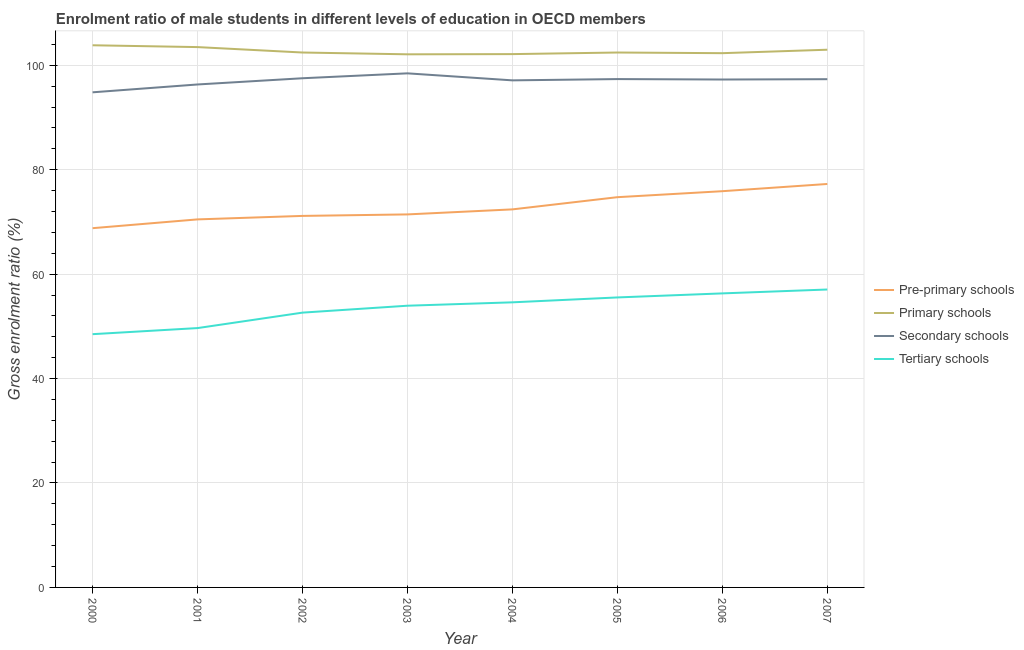Does the line corresponding to gross enrolment ratio(female) in pre-primary schools intersect with the line corresponding to gross enrolment ratio(female) in tertiary schools?
Offer a terse response. No. What is the gross enrolment ratio(female) in pre-primary schools in 2003?
Your answer should be very brief. 71.44. Across all years, what is the maximum gross enrolment ratio(female) in secondary schools?
Offer a very short reply. 98.45. Across all years, what is the minimum gross enrolment ratio(female) in tertiary schools?
Offer a terse response. 48.5. In which year was the gross enrolment ratio(female) in pre-primary schools maximum?
Provide a short and direct response. 2007. What is the total gross enrolment ratio(female) in tertiary schools in the graph?
Provide a short and direct response. 428.23. What is the difference between the gross enrolment ratio(female) in secondary schools in 2005 and that in 2007?
Offer a very short reply. 0.02. What is the difference between the gross enrolment ratio(female) in tertiary schools in 2001 and the gross enrolment ratio(female) in primary schools in 2003?
Offer a very short reply. -52.43. What is the average gross enrolment ratio(female) in secondary schools per year?
Offer a terse response. 97.02. In the year 2007, what is the difference between the gross enrolment ratio(female) in secondary schools and gross enrolment ratio(female) in pre-primary schools?
Give a very brief answer. 20.07. What is the ratio of the gross enrolment ratio(female) in tertiary schools in 2000 to that in 2006?
Offer a terse response. 0.86. Is the gross enrolment ratio(female) in pre-primary schools in 2000 less than that in 2004?
Your answer should be compact. Yes. Is the difference between the gross enrolment ratio(female) in tertiary schools in 2000 and 2007 greater than the difference between the gross enrolment ratio(female) in secondary schools in 2000 and 2007?
Give a very brief answer. No. What is the difference between the highest and the second highest gross enrolment ratio(female) in secondary schools?
Your answer should be very brief. 0.94. What is the difference between the highest and the lowest gross enrolment ratio(female) in tertiary schools?
Keep it short and to the point. 8.55. In how many years, is the gross enrolment ratio(female) in secondary schools greater than the average gross enrolment ratio(female) in secondary schools taken over all years?
Your answer should be very brief. 6. Is it the case that in every year, the sum of the gross enrolment ratio(female) in pre-primary schools and gross enrolment ratio(female) in primary schools is greater than the gross enrolment ratio(female) in secondary schools?
Offer a very short reply. Yes. How many years are there in the graph?
Offer a terse response. 8. Are the values on the major ticks of Y-axis written in scientific E-notation?
Give a very brief answer. No. Does the graph contain grids?
Make the answer very short. Yes. What is the title of the graph?
Offer a terse response. Enrolment ratio of male students in different levels of education in OECD members. What is the Gross enrolment ratio (%) of Pre-primary schools in 2000?
Offer a very short reply. 68.8. What is the Gross enrolment ratio (%) in Primary schools in 2000?
Make the answer very short. 103.83. What is the Gross enrolment ratio (%) of Secondary schools in 2000?
Give a very brief answer. 94.82. What is the Gross enrolment ratio (%) of Tertiary schools in 2000?
Offer a very short reply. 48.5. What is the Gross enrolment ratio (%) of Pre-primary schools in 2001?
Offer a very short reply. 70.48. What is the Gross enrolment ratio (%) in Primary schools in 2001?
Keep it short and to the point. 103.48. What is the Gross enrolment ratio (%) in Secondary schools in 2001?
Your answer should be very brief. 96.32. What is the Gross enrolment ratio (%) of Tertiary schools in 2001?
Make the answer very short. 49.67. What is the Gross enrolment ratio (%) of Pre-primary schools in 2002?
Your response must be concise. 71.15. What is the Gross enrolment ratio (%) of Primary schools in 2002?
Give a very brief answer. 102.44. What is the Gross enrolment ratio (%) of Secondary schools in 2002?
Provide a succinct answer. 97.51. What is the Gross enrolment ratio (%) of Tertiary schools in 2002?
Make the answer very short. 52.63. What is the Gross enrolment ratio (%) of Pre-primary schools in 2003?
Ensure brevity in your answer.  71.44. What is the Gross enrolment ratio (%) in Primary schools in 2003?
Ensure brevity in your answer.  102.09. What is the Gross enrolment ratio (%) in Secondary schools in 2003?
Offer a very short reply. 98.45. What is the Gross enrolment ratio (%) of Tertiary schools in 2003?
Make the answer very short. 53.95. What is the Gross enrolment ratio (%) of Pre-primary schools in 2004?
Ensure brevity in your answer.  72.4. What is the Gross enrolment ratio (%) in Primary schools in 2004?
Your answer should be very brief. 102.13. What is the Gross enrolment ratio (%) of Secondary schools in 2004?
Your answer should be very brief. 97.11. What is the Gross enrolment ratio (%) in Tertiary schools in 2004?
Keep it short and to the point. 54.6. What is the Gross enrolment ratio (%) of Pre-primary schools in 2005?
Provide a succinct answer. 74.73. What is the Gross enrolment ratio (%) of Primary schools in 2005?
Your response must be concise. 102.44. What is the Gross enrolment ratio (%) in Secondary schools in 2005?
Offer a very short reply. 97.35. What is the Gross enrolment ratio (%) in Tertiary schools in 2005?
Give a very brief answer. 55.53. What is the Gross enrolment ratio (%) of Pre-primary schools in 2006?
Your answer should be very brief. 75.88. What is the Gross enrolment ratio (%) of Primary schools in 2006?
Provide a short and direct response. 102.31. What is the Gross enrolment ratio (%) in Secondary schools in 2006?
Keep it short and to the point. 97.27. What is the Gross enrolment ratio (%) in Tertiary schools in 2006?
Ensure brevity in your answer.  56.31. What is the Gross enrolment ratio (%) in Pre-primary schools in 2007?
Ensure brevity in your answer.  77.26. What is the Gross enrolment ratio (%) of Primary schools in 2007?
Offer a very short reply. 102.97. What is the Gross enrolment ratio (%) of Secondary schools in 2007?
Provide a short and direct response. 97.33. What is the Gross enrolment ratio (%) of Tertiary schools in 2007?
Your answer should be very brief. 57.05. Across all years, what is the maximum Gross enrolment ratio (%) in Pre-primary schools?
Your response must be concise. 77.26. Across all years, what is the maximum Gross enrolment ratio (%) of Primary schools?
Offer a very short reply. 103.83. Across all years, what is the maximum Gross enrolment ratio (%) of Secondary schools?
Your response must be concise. 98.45. Across all years, what is the maximum Gross enrolment ratio (%) of Tertiary schools?
Provide a short and direct response. 57.05. Across all years, what is the minimum Gross enrolment ratio (%) in Pre-primary schools?
Provide a short and direct response. 68.8. Across all years, what is the minimum Gross enrolment ratio (%) of Primary schools?
Offer a very short reply. 102.09. Across all years, what is the minimum Gross enrolment ratio (%) of Secondary schools?
Your answer should be compact. 94.82. Across all years, what is the minimum Gross enrolment ratio (%) of Tertiary schools?
Give a very brief answer. 48.5. What is the total Gross enrolment ratio (%) in Pre-primary schools in the graph?
Offer a very short reply. 582.13. What is the total Gross enrolment ratio (%) in Primary schools in the graph?
Your answer should be very brief. 821.69. What is the total Gross enrolment ratio (%) of Secondary schools in the graph?
Make the answer very short. 776.14. What is the total Gross enrolment ratio (%) in Tertiary schools in the graph?
Offer a very short reply. 428.23. What is the difference between the Gross enrolment ratio (%) of Pre-primary schools in 2000 and that in 2001?
Provide a succinct answer. -1.68. What is the difference between the Gross enrolment ratio (%) of Primary schools in 2000 and that in 2001?
Your answer should be very brief. 0.35. What is the difference between the Gross enrolment ratio (%) of Secondary schools in 2000 and that in 2001?
Keep it short and to the point. -1.5. What is the difference between the Gross enrolment ratio (%) of Tertiary schools in 2000 and that in 2001?
Your answer should be very brief. -1.17. What is the difference between the Gross enrolment ratio (%) of Pre-primary schools in 2000 and that in 2002?
Offer a terse response. -2.35. What is the difference between the Gross enrolment ratio (%) of Primary schools in 2000 and that in 2002?
Make the answer very short. 1.39. What is the difference between the Gross enrolment ratio (%) in Secondary schools in 2000 and that in 2002?
Your response must be concise. -2.69. What is the difference between the Gross enrolment ratio (%) in Tertiary schools in 2000 and that in 2002?
Provide a short and direct response. -4.13. What is the difference between the Gross enrolment ratio (%) in Pre-primary schools in 2000 and that in 2003?
Your answer should be compact. -2.64. What is the difference between the Gross enrolment ratio (%) in Primary schools in 2000 and that in 2003?
Your answer should be very brief. 1.73. What is the difference between the Gross enrolment ratio (%) of Secondary schools in 2000 and that in 2003?
Make the answer very short. -3.63. What is the difference between the Gross enrolment ratio (%) of Tertiary schools in 2000 and that in 2003?
Offer a terse response. -5.45. What is the difference between the Gross enrolment ratio (%) of Pre-primary schools in 2000 and that in 2004?
Your answer should be very brief. -3.6. What is the difference between the Gross enrolment ratio (%) in Primary schools in 2000 and that in 2004?
Keep it short and to the point. 1.69. What is the difference between the Gross enrolment ratio (%) of Secondary schools in 2000 and that in 2004?
Your answer should be compact. -2.29. What is the difference between the Gross enrolment ratio (%) in Tertiary schools in 2000 and that in 2004?
Offer a very short reply. -6.1. What is the difference between the Gross enrolment ratio (%) in Pre-primary schools in 2000 and that in 2005?
Give a very brief answer. -5.94. What is the difference between the Gross enrolment ratio (%) in Primary schools in 2000 and that in 2005?
Offer a very short reply. 1.39. What is the difference between the Gross enrolment ratio (%) of Secondary schools in 2000 and that in 2005?
Your answer should be compact. -2.54. What is the difference between the Gross enrolment ratio (%) of Tertiary schools in 2000 and that in 2005?
Offer a terse response. -7.03. What is the difference between the Gross enrolment ratio (%) in Pre-primary schools in 2000 and that in 2006?
Your answer should be compact. -7.08. What is the difference between the Gross enrolment ratio (%) of Primary schools in 2000 and that in 2006?
Your answer should be very brief. 1.51. What is the difference between the Gross enrolment ratio (%) in Secondary schools in 2000 and that in 2006?
Offer a very short reply. -2.45. What is the difference between the Gross enrolment ratio (%) in Tertiary schools in 2000 and that in 2006?
Ensure brevity in your answer.  -7.81. What is the difference between the Gross enrolment ratio (%) in Pre-primary schools in 2000 and that in 2007?
Keep it short and to the point. -8.47. What is the difference between the Gross enrolment ratio (%) in Primary schools in 2000 and that in 2007?
Ensure brevity in your answer.  0.85. What is the difference between the Gross enrolment ratio (%) in Secondary schools in 2000 and that in 2007?
Your answer should be compact. -2.51. What is the difference between the Gross enrolment ratio (%) in Tertiary schools in 2000 and that in 2007?
Give a very brief answer. -8.55. What is the difference between the Gross enrolment ratio (%) in Pre-primary schools in 2001 and that in 2002?
Your answer should be very brief. -0.67. What is the difference between the Gross enrolment ratio (%) of Primary schools in 2001 and that in 2002?
Your answer should be compact. 1.04. What is the difference between the Gross enrolment ratio (%) in Secondary schools in 2001 and that in 2002?
Your response must be concise. -1.19. What is the difference between the Gross enrolment ratio (%) of Tertiary schools in 2001 and that in 2002?
Offer a terse response. -2.96. What is the difference between the Gross enrolment ratio (%) of Pre-primary schools in 2001 and that in 2003?
Provide a short and direct response. -0.96. What is the difference between the Gross enrolment ratio (%) in Primary schools in 2001 and that in 2003?
Your response must be concise. 1.38. What is the difference between the Gross enrolment ratio (%) in Secondary schools in 2001 and that in 2003?
Your response must be concise. -2.13. What is the difference between the Gross enrolment ratio (%) of Tertiary schools in 2001 and that in 2003?
Your response must be concise. -4.28. What is the difference between the Gross enrolment ratio (%) of Pre-primary schools in 2001 and that in 2004?
Your answer should be compact. -1.92. What is the difference between the Gross enrolment ratio (%) of Primary schools in 2001 and that in 2004?
Make the answer very short. 1.34. What is the difference between the Gross enrolment ratio (%) of Secondary schools in 2001 and that in 2004?
Your response must be concise. -0.79. What is the difference between the Gross enrolment ratio (%) in Tertiary schools in 2001 and that in 2004?
Offer a terse response. -4.93. What is the difference between the Gross enrolment ratio (%) in Pre-primary schools in 2001 and that in 2005?
Your answer should be very brief. -4.25. What is the difference between the Gross enrolment ratio (%) in Primary schools in 2001 and that in 2005?
Offer a very short reply. 1.04. What is the difference between the Gross enrolment ratio (%) of Secondary schools in 2001 and that in 2005?
Offer a very short reply. -1.03. What is the difference between the Gross enrolment ratio (%) of Tertiary schools in 2001 and that in 2005?
Your response must be concise. -5.87. What is the difference between the Gross enrolment ratio (%) of Pre-primary schools in 2001 and that in 2006?
Provide a short and direct response. -5.4. What is the difference between the Gross enrolment ratio (%) in Primary schools in 2001 and that in 2006?
Provide a short and direct response. 1.16. What is the difference between the Gross enrolment ratio (%) of Secondary schools in 2001 and that in 2006?
Provide a succinct answer. -0.95. What is the difference between the Gross enrolment ratio (%) in Tertiary schools in 2001 and that in 2006?
Provide a short and direct response. -6.64. What is the difference between the Gross enrolment ratio (%) in Pre-primary schools in 2001 and that in 2007?
Offer a terse response. -6.78. What is the difference between the Gross enrolment ratio (%) of Primary schools in 2001 and that in 2007?
Provide a succinct answer. 0.5. What is the difference between the Gross enrolment ratio (%) of Secondary schools in 2001 and that in 2007?
Give a very brief answer. -1.01. What is the difference between the Gross enrolment ratio (%) in Tertiary schools in 2001 and that in 2007?
Give a very brief answer. -7.39. What is the difference between the Gross enrolment ratio (%) of Pre-primary schools in 2002 and that in 2003?
Keep it short and to the point. -0.29. What is the difference between the Gross enrolment ratio (%) in Primary schools in 2002 and that in 2003?
Make the answer very short. 0.34. What is the difference between the Gross enrolment ratio (%) of Secondary schools in 2002 and that in 2003?
Ensure brevity in your answer.  -0.94. What is the difference between the Gross enrolment ratio (%) in Tertiary schools in 2002 and that in 2003?
Make the answer very short. -1.32. What is the difference between the Gross enrolment ratio (%) in Pre-primary schools in 2002 and that in 2004?
Offer a very short reply. -1.25. What is the difference between the Gross enrolment ratio (%) in Primary schools in 2002 and that in 2004?
Provide a short and direct response. 0.3. What is the difference between the Gross enrolment ratio (%) in Secondary schools in 2002 and that in 2004?
Offer a terse response. 0.4. What is the difference between the Gross enrolment ratio (%) in Tertiary schools in 2002 and that in 2004?
Ensure brevity in your answer.  -1.97. What is the difference between the Gross enrolment ratio (%) in Pre-primary schools in 2002 and that in 2005?
Offer a very short reply. -3.59. What is the difference between the Gross enrolment ratio (%) of Primary schools in 2002 and that in 2005?
Give a very brief answer. -0. What is the difference between the Gross enrolment ratio (%) of Secondary schools in 2002 and that in 2005?
Provide a short and direct response. 0.16. What is the difference between the Gross enrolment ratio (%) in Tertiary schools in 2002 and that in 2005?
Offer a terse response. -2.91. What is the difference between the Gross enrolment ratio (%) of Pre-primary schools in 2002 and that in 2006?
Provide a succinct answer. -4.73. What is the difference between the Gross enrolment ratio (%) in Primary schools in 2002 and that in 2006?
Your response must be concise. 0.12. What is the difference between the Gross enrolment ratio (%) in Secondary schools in 2002 and that in 2006?
Give a very brief answer. 0.24. What is the difference between the Gross enrolment ratio (%) in Tertiary schools in 2002 and that in 2006?
Offer a very short reply. -3.68. What is the difference between the Gross enrolment ratio (%) of Pre-primary schools in 2002 and that in 2007?
Provide a succinct answer. -6.12. What is the difference between the Gross enrolment ratio (%) in Primary schools in 2002 and that in 2007?
Your response must be concise. -0.54. What is the difference between the Gross enrolment ratio (%) of Secondary schools in 2002 and that in 2007?
Offer a very short reply. 0.18. What is the difference between the Gross enrolment ratio (%) in Tertiary schools in 2002 and that in 2007?
Your answer should be very brief. -4.43. What is the difference between the Gross enrolment ratio (%) of Pre-primary schools in 2003 and that in 2004?
Provide a short and direct response. -0.96. What is the difference between the Gross enrolment ratio (%) of Primary schools in 2003 and that in 2004?
Make the answer very short. -0.04. What is the difference between the Gross enrolment ratio (%) of Secondary schools in 2003 and that in 2004?
Give a very brief answer. 1.34. What is the difference between the Gross enrolment ratio (%) of Tertiary schools in 2003 and that in 2004?
Keep it short and to the point. -0.65. What is the difference between the Gross enrolment ratio (%) of Pre-primary schools in 2003 and that in 2005?
Your answer should be very brief. -3.3. What is the difference between the Gross enrolment ratio (%) of Primary schools in 2003 and that in 2005?
Your answer should be compact. -0.34. What is the difference between the Gross enrolment ratio (%) in Secondary schools in 2003 and that in 2005?
Ensure brevity in your answer.  1.1. What is the difference between the Gross enrolment ratio (%) of Tertiary schools in 2003 and that in 2005?
Provide a short and direct response. -1.59. What is the difference between the Gross enrolment ratio (%) in Pre-primary schools in 2003 and that in 2006?
Your answer should be compact. -4.44. What is the difference between the Gross enrolment ratio (%) of Primary schools in 2003 and that in 2006?
Provide a succinct answer. -0.22. What is the difference between the Gross enrolment ratio (%) of Secondary schools in 2003 and that in 2006?
Keep it short and to the point. 1.18. What is the difference between the Gross enrolment ratio (%) in Tertiary schools in 2003 and that in 2006?
Ensure brevity in your answer.  -2.36. What is the difference between the Gross enrolment ratio (%) of Pre-primary schools in 2003 and that in 2007?
Offer a very short reply. -5.83. What is the difference between the Gross enrolment ratio (%) of Primary schools in 2003 and that in 2007?
Keep it short and to the point. -0.88. What is the difference between the Gross enrolment ratio (%) in Secondary schools in 2003 and that in 2007?
Keep it short and to the point. 1.12. What is the difference between the Gross enrolment ratio (%) in Tertiary schools in 2003 and that in 2007?
Give a very brief answer. -3.1. What is the difference between the Gross enrolment ratio (%) in Pre-primary schools in 2004 and that in 2005?
Give a very brief answer. -2.34. What is the difference between the Gross enrolment ratio (%) of Primary schools in 2004 and that in 2005?
Your answer should be compact. -0.3. What is the difference between the Gross enrolment ratio (%) of Secondary schools in 2004 and that in 2005?
Give a very brief answer. -0.24. What is the difference between the Gross enrolment ratio (%) of Tertiary schools in 2004 and that in 2005?
Give a very brief answer. -0.94. What is the difference between the Gross enrolment ratio (%) in Pre-primary schools in 2004 and that in 2006?
Ensure brevity in your answer.  -3.48. What is the difference between the Gross enrolment ratio (%) in Primary schools in 2004 and that in 2006?
Give a very brief answer. -0.18. What is the difference between the Gross enrolment ratio (%) of Secondary schools in 2004 and that in 2006?
Your answer should be compact. -0.16. What is the difference between the Gross enrolment ratio (%) of Tertiary schools in 2004 and that in 2006?
Ensure brevity in your answer.  -1.71. What is the difference between the Gross enrolment ratio (%) of Pre-primary schools in 2004 and that in 2007?
Your answer should be very brief. -4.86. What is the difference between the Gross enrolment ratio (%) in Primary schools in 2004 and that in 2007?
Provide a succinct answer. -0.84. What is the difference between the Gross enrolment ratio (%) in Secondary schools in 2004 and that in 2007?
Your response must be concise. -0.22. What is the difference between the Gross enrolment ratio (%) of Tertiary schools in 2004 and that in 2007?
Your answer should be compact. -2.46. What is the difference between the Gross enrolment ratio (%) of Pre-primary schools in 2005 and that in 2006?
Keep it short and to the point. -1.15. What is the difference between the Gross enrolment ratio (%) of Primary schools in 2005 and that in 2006?
Make the answer very short. 0.12. What is the difference between the Gross enrolment ratio (%) of Secondary schools in 2005 and that in 2006?
Keep it short and to the point. 0.09. What is the difference between the Gross enrolment ratio (%) of Tertiary schools in 2005 and that in 2006?
Your response must be concise. -0.77. What is the difference between the Gross enrolment ratio (%) of Pre-primary schools in 2005 and that in 2007?
Make the answer very short. -2.53. What is the difference between the Gross enrolment ratio (%) of Primary schools in 2005 and that in 2007?
Offer a terse response. -0.54. What is the difference between the Gross enrolment ratio (%) of Secondary schools in 2005 and that in 2007?
Provide a short and direct response. 0.02. What is the difference between the Gross enrolment ratio (%) in Tertiary schools in 2005 and that in 2007?
Make the answer very short. -1.52. What is the difference between the Gross enrolment ratio (%) of Pre-primary schools in 2006 and that in 2007?
Your answer should be very brief. -1.38. What is the difference between the Gross enrolment ratio (%) of Primary schools in 2006 and that in 2007?
Your answer should be compact. -0.66. What is the difference between the Gross enrolment ratio (%) in Secondary schools in 2006 and that in 2007?
Your response must be concise. -0.06. What is the difference between the Gross enrolment ratio (%) of Tertiary schools in 2006 and that in 2007?
Offer a very short reply. -0.74. What is the difference between the Gross enrolment ratio (%) in Pre-primary schools in 2000 and the Gross enrolment ratio (%) in Primary schools in 2001?
Your response must be concise. -34.68. What is the difference between the Gross enrolment ratio (%) in Pre-primary schools in 2000 and the Gross enrolment ratio (%) in Secondary schools in 2001?
Offer a very short reply. -27.52. What is the difference between the Gross enrolment ratio (%) of Pre-primary schools in 2000 and the Gross enrolment ratio (%) of Tertiary schools in 2001?
Your answer should be very brief. 19.13. What is the difference between the Gross enrolment ratio (%) in Primary schools in 2000 and the Gross enrolment ratio (%) in Secondary schools in 2001?
Provide a succinct answer. 7.51. What is the difference between the Gross enrolment ratio (%) in Primary schools in 2000 and the Gross enrolment ratio (%) in Tertiary schools in 2001?
Provide a short and direct response. 54.16. What is the difference between the Gross enrolment ratio (%) of Secondary schools in 2000 and the Gross enrolment ratio (%) of Tertiary schools in 2001?
Your answer should be compact. 45.15. What is the difference between the Gross enrolment ratio (%) in Pre-primary schools in 2000 and the Gross enrolment ratio (%) in Primary schools in 2002?
Ensure brevity in your answer.  -33.64. What is the difference between the Gross enrolment ratio (%) of Pre-primary schools in 2000 and the Gross enrolment ratio (%) of Secondary schools in 2002?
Give a very brief answer. -28.71. What is the difference between the Gross enrolment ratio (%) of Pre-primary schools in 2000 and the Gross enrolment ratio (%) of Tertiary schools in 2002?
Provide a short and direct response. 16.17. What is the difference between the Gross enrolment ratio (%) of Primary schools in 2000 and the Gross enrolment ratio (%) of Secondary schools in 2002?
Make the answer very short. 6.32. What is the difference between the Gross enrolment ratio (%) in Primary schools in 2000 and the Gross enrolment ratio (%) in Tertiary schools in 2002?
Provide a short and direct response. 51.2. What is the difference between the Gross enrolment ratio (%) in Secondary schools in 2000 and the Gross enrolment ratio (%) in Tertiary schools in 2002?
Give a very brief answer. 42.19. What is the difference between the Gross enrolment ratio (%) of Pre-primary schools in 2000 and the Gross enrolment ratio (%) of Primary schools in 2003?
Offer a terse response. -33.3. What is the difference between the Gross enrolment ratio (%) in Pre-primary schools in 2000 and the Gross enrolment ratio (%) in Secondary schools in 2003?
Give a very brief answer. -29.65. What is the difference between the Gross enrolment ratio (%) in Pre-primary schools in 2000 and the Gross enrolment ratio (%) in Tertiary schools in 2003?
Offer a terse response. 14.85. What is the difference between the Gross enrolment ratio (%) in Primary schools in 2000 and the Gross enrolment ratio (%) in Secondary schools in 2003?
Your answer should be very brief. 5.38. What is the difference between the Gross enrolment ratio (%) of Primary schools in 2000 and the Gross enrolment ratio (%) of Tertiary schools in 2003?
Your answer should be compact. 49.88. What is the difference between the Gross enrolment ratio (%) in Secondary schools in 2000 and the Gross enrolment ratio (%) in Tertiary schools in 2003?
Offer a very short reply. 40.87. What is the difference between the Gross enrolment ratio (%) in Pre-primary schools in 2000 and the Gross enrolment ratio (%) in Primary schools in 2004?
Your response must be concise. -33.34. What is the difference between the Gross enrolment ratio (%) in Pre-primary schools in 2000 and the Gross enrolment ratio (%) in Secondary schools in 2004?
Provide a short and direct response. -28.31. What is the difference between the Gross enrolment ratio (%) in Pre-primary schools in 2000 and the Gross enrolment ratio (%) in Tertiary schools in 2004?
Give a very brief answer. 14.2. What is the difference between the Gross enrolment ratio (%) in Primary schools in 2000 and the Gross enrolment ratio (%) in Secondary schools in 2004?
Ensure brevity in your answer.  6.72. What is the difference between the Gross enrolment ratio (%) of Primary schools in 2000 and the Gross enrolment ratio (%) of Tertiary schools in 2004?
Offer a very short reply. 49.23. What is the difference between the Gross enrolment ratio (%) of Secondary schools in 2000 and the Gross enrolment ratio (%) of Tertiary schools in 2004?
Your answer should be very brief. 40.22. What is the difference between the Gross enrolment ratio (%) in Pre-primary schools in 2000 and the Gross enrolment ratio (%) in Primary schools in 2005?
Provide a succinct answer. -33.64. What is the difference between the Gross enrolment ratio (%) in Pre-primary schools in 2000 and the Gross enrolment ratio (%) in Secondary schools in 2005?
Ensure brevity in your answer.  -28.55. What is the difference between the Gross enrolment ratio (%) in Pre-primary schools in 2000 and the Gross enrolment ratio (%) in Tertiary schools in 2005?
Make the answer very short. 13.26. What is the difference between the Gross enrolment ratio (%) of Primary schools in 2000 and the Gross enrolment ratio (%) of Secondary schools in 2005?
Provide a short and direct response. 6.47. What is the difference between the Gross enrolment ratio (%) of Primary schools in 2000 and the Gross enrolment ratio (%) of Tertiary schools in 2005?
Provide a succinct answer. 48.29. What is the difference between the Gross enrolment ratio (%) in Secondary schools in 2000 and the Gross enrolment ratio (%) in Tertiary schools in 2005?
Provide a short and direct response. 39.28. What is the difference between the Gross enrolment ratio (%) of Pre-primary schools in 2000 and the Gross enrolment ratio (%) of Primary schools in 2006?
Your answer should be very brief. -33.52. What is the difference between the Gross enrolment ratio (%) of Pre-primary schools in 2000 and the Gross enrolment ratio (%) of Secondary schools in 2006?
Make the answer very short. -28.47. What is the difference between the Gross enrolment ratio (%) in Pre-primary schools in 2000 and the Gross enrolment ratio (%) in Tertiary schools in 2006?
Offer a very short reply. 12.49. What is the difference between the Gross enrolment ratio (%) in Primary schools in 2000 and the Gross enrolment ratio (%) in Secondary schools in 2006?
Your response must be concise. 6.56. What is the difference between the Gross enrolment ratio (%) of Primary schools in 2000 and the Gross enrolment ratio (%) of Tertiary schools in 2006?
Give a very brief answer. 47.52. What is the difference between the Gross enrolment ratio (%) of Secondary schools in 2000 and the Gross enrolment ratio (%) of Tertiary schools in 2006?
Your response must be concise. 38.51. What is the difference between the Gross enrolment ratio (%) in Pre-primary schools in 2000 and the Gross enrolment ratio (%) in Primary schools in 2007?
Keep it short and to the point. -34.18. What is the difference between the Gross enrolment ratio (%) in Pre-primary schools in 2000 and the Gross enrolment ratio (%) in Secondary schools in 2007?
Provide a succinct answer. -28.53. What is the difference between the Gross enrolment ratio (%) in Pre-primary schools in 2000 and the Gross enrolment ratio (%) in Tertiary schools in 2007?
Provide a succinct answer. 11.74. What is the difference between the Gross enrolment ratio (%) in Primary schools in 2000 and the Gross enrolment ratio (%) in Secondary schools in 2007?
Provide a succinct answer. 6.5. What is the difference between the Gross enrolment ratio (%) of Primary schools in 2000 and the Gross enrolment ratio (%) of Tertiary schools in 2007?
Provide a succinct answer. 46.77. What is the difference between the Gross enrolment ratio (%) in Secondary schools in 2000 and the Gross enrolment ratio (%) in Tertiary schools in 2007?
Keep it short and to the point. 37.76. What is the difference between the Gross enrolment ratio (%) in Pre-primary schools in 2001 and the Gross enrolment ratio (%) in Primary schools in 2002?
Your response must be concise. -31.96. What is the difference between the Gross enrolment ratio (%) of Pre-primary schools in 2001 and the Gross enrolment ratio (%) of Secondary schools in 2002?
Give a very brief answer. -27.03. What is the difference between the Gross enrolment ratio (%) in Pre-primary schools in 2001 and the Gross enrolment ratio (%) in Tertiary schools in 2002?
Your response must be concise. 17.85. What is the difference between the Gross enrolment ratio (%) of Primary schools in 2001 and the Gross enrolment ratio (%) of Secondary schools in 2002?
Provide a short and direct response. 5.97. What is the difference between the Gross enrolment ratio (%) in Primary schools in 2001 and the Gross enrolment ratio (%) in Tertiary schools in 2002?
Your answer should be compact. 50.85. What is the difference between the Gross enrolment ratio (%) of Secondary schools in 2001 and the Gross enrolment ratio (%) of Tertiary schools in 2002?
Give a very brief answer. 43.69. What is the difference between the Gross enrolment ratio (%) in Pre-primary schools in 2001 and the Gross enrolment ratio (%) in Primary schools in 2003?
Your answer should be compact. -31.61. What is the difference between the Gross enrolment ratio (%) in Pre-primary schools in 2001 and the Gross enrolment ratio (%) in Secondary schools in 2003?
Provide a succinct answer. -27.97. What is the difference between the Gross enrolment ratio (%) of Pre-primary schools in 2001 and the Gross enrolment ratio (%) of Tertiary schools in 2003?
Make the answer very short. 16.53. What is the difference between the Gross enrolment ratio (%) of Primary schools in 2001 and the Gross enrolment ratio (%) of Secondary schools in 2003?
Offer a terse response. 5.03. What is the difference between the Gross enrolment ratio (%) in Primary schools in 2001 and the Gross enrolment ratio (%) in Tertiary schools in 2003?
Offer a very short reply. 49.53. What is the difference between the Gross enrolment ratio (%) in Secondary schools in 2001 and the Gross enrolment ratio (%) in Tertiary schools in 2003?
Offer a very short reply. 42.37. What is the difference between the Gross enrolment ratio (%) of Pre-primary schools in 2001 and the Gross enrolment ratio (%) of Primary schools in 2004?
Your answer should be very brief. -31.65. What is the difference between the Gross enrolment ratio (%) of Pre-primary schools in 2001 and the Gross enrolment ratio (%) of Secondary schools in 2004?
Your answer should be very brief. -26.63. What is the difference between the Gross enrolment ratio (%) in Pre-primary schools in 2001 and the Gross enrolment ratio (%) in Tertiary schools in 2004?
Ensure brevity in your answer.  15.88. What is the difference between the Gross enrolment ratio (%) in Primary schools in 2001 and the Gross enrolment ratio (%) in Secondary schools in 2004?
Keep it short and to the point. 6.37. What is the difference between the Gross enrolment ratio (%) of Primary schools in 2001 and the Gross enrolment ratio (%) of Tertiary schools in 2004?
Your answer should be very brief. 48.88. What is the difference between the Gross enrolment ratio (%) of Secondary schools in 2001 and the Gross enrolment ratio (%) of Tertiary schools in 2004?
Offer a terse response. 41.72. What is the difference between the Gross enrolment ratio (%) in Pre-primary schools in 2001 and the Gross enrolment ratio (%) in Primary schools in 2005?
Provide a short and direct response. -31.96. What is the difference between the Gross enrolment ratio (%) of Pre-primary schools in 2001 and the Gross enrolment ratio (%) of Secondary schools in 2005?
Your answer should be very brief. -26.87. What is the difference between the Gross enrolment ratio (%) of Pre-primary schools in 2001 and the Gross enrolment ratio (%) of Tertiary schools in 2005?
Your answer should be compact. 14.95. What is the difference between the Gross enrolment ratio (%) of Primary schools in 2001 and the Gross enrolment ratio (%) of Secondary schools in 2005?
Provide a succinct answer. 6.12. What is the difference between the Gross enrolment ratio (%) in Primary schools in 2001 and the Gross enrolment ratio (%) in Tertiary schools in 2005?
Your response must be concise. 47.94. What is the difference between the Gross enrolment ratio (%) in Secondary schools in 2001 and the Gross enrolment ratio (%) in Tertiary schools in 2005?
Give a very brief answer. 40.78. What is the difference between the Gross enrolment ratio (%) in Pre-primary schools in 2001 and the Gross enrolment ratio (%) in Primary schools in 2006?
Give a very brief answer. -31.83. What is the difference between the Gross enrolment ratio (%) in Pre-primary schools in 2001 and the Gross enrolment ratio (%) in Secondary schools in 2006?
Give a very brief answer. -26.79. What is the difference between the Gross enrolment ratio (%) in Pre-primary schools in 2001 and the Gross enrolment ratio (%) in Tertiary schools in 2006?
Provide a succinct answer. 14.17. What is the difference between the Gross enrolment ratio (%) in Primary schools in 2001 and the Gross enrolment ratio (%) in Secondary schools in 2006?
Offer a very short reply. 6.21. What is the difference between the Gross enrolment ratio (%) of Primary schools in 2001 and the Gross enrolment ratio (%) of Tertiary schools in 2006?
Make the answer very short. 47.17. What is the difference between the Gross enrolment ratio (%) of Secondary schools in 2001 and the Gross enrolment ratio (%) of Tertiary schools in 2006?
Ensure brevity in your answer.  40.01. What is the difference between the Gross enrolment ratio (%) in Pre-primary schools in 2001 and the Gross enrolment ratio (%) in Primary schools in 2007?
Offer a very short reply. -32.49. What is the difference between the Gross enrolment ratio (%) of Pre-primary schools in 2001 and the Gross enrolment ratio (%) of Secondary schools in 2007?
Provide a succinct answer. -26.85. What is the difference between the Gross enrolment ratio (%) of Pre-primary schools in 2001 and the Gross enrolment ratio (%) of Tertiary schools in 2007?
Ensure brevity in your answer.  13.43. What is the difference between the Gross enrolment ratio (%) in Primary schools in 2001 and the Gross enrolment ratio (%) in Secondary schools in 2007?
Your response must be concise. 6.15. What is the difference between the Gross enrolment ratio (%) of Primary schools in 2001 and the Gross enrolment ratio (%) of Tertiary schools in 2007?
Your answer should be very brief. 46.42. What is the difference between the Gross enrolment ratio (%) of Secondary schools in 2001 and the Gross enrolment ratio (%) of Tertiary schools in 2007?
Give a very brief answer. 39.27. What is the difference between the Gross enrolment ratio (%) of Pre-primary schools in 2002 and the Gross enrolment ratio (%) of Primary schools in 2003?
Provide a short and direct response. -30.95. What is the difference between the Gross enrolment ratio (%) in Pre-primary schools in 2002 and the Gross enrolment ratio (%) in Secondary schools in 2003?
Make the answer very short. -27.3. What is the difference between the Gross enrolment ratio (%) of Pre-primary schools in 2002 and the Gross enrolment ratio (%) of Tertiary schools in 2003?
Provide a succinct answer. 17.2. What is the difference between the Gross enrolment ratio (%) in Primary schools in 2002 and the Gross enrolment ratio (%) in Secondary schools in 2003?
Provide a short and direct response. 3.99. What is the difference between the Gross enrolment ratio (%) of Primary schools in 2002 and the Gross enrolment ratio (%) of Tertiary schools in 2003?
Make the answer very short. 48.49. What is the difference between the Gross enrolment ratio (%) of Secondary schools in 2002 and the Gross enrolment ratio (%) of Tertiary schools in 2003?
Give a very brief answer. 43.56. What is the difference between the Gross enrolment ratio (%) of Pre-primary schools in 2002 and the Gross enrolment ratio (%) of Primary schools in 2004?
Provide a succinct answer. -30.99. What is the difference between the Gross enrolment ratio (%) of Pre-primary schools in 2002 and the Gross enrolment ratio (%) of Secondary schools in 2004?
Your answer should be very brief. -25.96. What is the difference between the Gross enrolment ratio (%) in Pre-primary schools in 2002 and the Gross enrolment ratio (%) in Tertiary schools in 2004?
Your answer should be very brief. 16.55. What is the difference between the Gross enrolment ratio (%) of Primary schools in 2002 and the Gross enrolment ratio (%) of Secondary schools in 2004?
Keep it short and to the point. 5.33. What is the difference between the Gross enrolment ratio (%) of Primary schools in 2002 and the Gross enrolment ratio (%) of Tertiary schools in 2004?
Provide a short and direct response. 47.84. What is the difference between the Gross enrolment ratio (%) of Secondary schools in 2002 and the Gross enrolment ratio (%) of Tertiary schools in 2004?
Give a very brief answer. 42.91. What is the difference between the Gross enrolment ratio (%) of Pre-primary schools in 2002 and the Gross enrolment ratio (%) of Primary schools in 2005?
Make the answer very short. -31.29. What is the difference between the Gross enrolment ratio (%) in Pre-primary schools in 2002 and the Gross enrolment ratio (%) in Secondary schools in 2005?
Your answer should be compact. -26.2. What is the difference between the Gross enrolment ratio (%) in Pre-primary schools in 2002 and the Gross enrolment ratio (%) in Tertiary schools in 2005?
Offer a very short reply. 15.61. What is the difference between the Gross enrolment ratio (%) of Primary schools in 2002 and the Gross enrolment ratio (%) of Secondary schools in 2005?
Provide a short and direct response. 5.09. What is the difference between the Gross enrolment ratio (%) in Primary schools in 2002 and the Gross enrolment ratio (%) in Tertiary schools in 2005?
Offer a terse response. 46.9. What is the difference between the Gross enrolment ratio (%) in Secondary schools in 2002 and the Gross enrolment ratio (%) in Tertiary schools in 2005?
Ensure brevity in your answer.  41.97. What is the difference between the Gross enrolment ratio (%) of Pre-primary schools in 2002 and the Gross enrolment ratio (%) of Primary schools in 2006?
Give a very brief answer. -31.17. What is the difference between the Gross enrolment ratio (%) of Pre-primary schools in 2002 and the Gross enrolment ratio (%) of Secondary schools in 2006?
Your answer should be compact. -26.12. What is the difference between the Gross enrolment ratio (%) in Pre-primary schools in 2002 and the Gross enrolment ratio (%) in Tertiary schools in 2006?
Provide a short and direct response. 14.84. What is the difference between the Gross enrolment ratio (%) of Primary schools in 2002 and the Gross enrolment ratio (%) of Secondary schools in 2006?
Make the answer very short. 5.17. What is the difference between the Gross enrolment ratio (%) of Primary schools in 2002 and the Gross enrolment ratio (%) of Tertiary schools in 2006?
Your answer should be very brief. 46.13. What is the difference between the Gross enrolment ratio (%) of Secondary schools in 2002 and the Gross enrolment ratio (%) of Tertiary schools in 2006?
Keep it short and to the point. 41.2. What is the difference between the Gross enrolment ratio (%) in Pre-primary schools in 2002 and the Gross enrolment ratio (%) in Primary schools in 2007?
Provide a succinct answer. -31.83. What is the difference between the Gross enrolment ratio (%) of Pre-primary schools in 2002 and the Gross enrolment ratio (%) of Secondary schools in 2007?
Offer a terse response. -26.18. What is the difference between the Gross enrolment ratio (%) in Pre-primary schools in 2002 and the Gross enrolment ratio (%) in Tertiary schools in 2007?
Offer a very short reply. 14.09. What is the difference between the Gross enrolment ratio (%) in Primary schools in 2002 and the Gross enrolment ratio (%) in Secondary schools in 2007?
Keep it short and to the point. 5.11. What is the difference between the Gross enrolment ratio (%) of Primary schools in 2002 and the Gross enrolment ratio (%) of Tertiary schools in 2007?
Keep it short and to the point. 45.38. What is the difference between the Gross enrolment ratio (%) in Secondary schools in 2002 and the Gross enrolment ratio (%) in Tertiary schools in 2007?
Provide a short and direct response. 40.46. What is the difference between the Gross enrolment ratio (%) in Pre-primary schools in 2003 and the Gross enrolment ratio (%) in Primary schools in 2004?
Your response must be concise. -30.7. What is the difference between the Gross enrolment ratio (%) of Pre-primary schools in 2003 and the Gross enrolment ratio (%) of Secondary schools in 2004?
Make the answer very short. -25.67. What is the difference between the Gross enrolment ratio (%) of Pre-primary schools in 2003 and the Gross enrolment ratio (%) of Tertiary schools in 2004?
Offer a terse response. 16.84. What is the difference between the Gross enrolment ratio (%) of Primary schools in 2003 and the Gross enrolment ratio (%) of Secondary schools in 2004?
Your answer should be very brief. 4.99. What is the difference between the Gross enrolment ratio (%) of Primary schools in 2003 and the Gross enrolment ratio (%) of Tertiary schools in 2004?
Provide a succinct answer. 47.5. What is the difference between the Gross enrolment ratio (%) of Secondary schools in 2003 and the Gross enrolment ratio (%) of Tertiary schools in 2004?
Provide a succinct answer. 43.85. What is the difference between the Gross enrolment ratio (%) of Pre-primary schools in 2003 and the Gross enrolment ratio (%) of Primary schools in 2005?
Make the answer very short. -31. What is the difference between the Gross enrolment ratio (%) of Pre-primary schools in 2003 and the Gross enrolment ratio (%) of Secondary schools in 2005?
Ensure brevity in your answer.  -25.92. What is the difference between the Gross enrolment ratio (%) in Pre-primary schools in 2003 and the Gross enrolment ratio (%) in Tertiary schools in 2005?
Give a very brief answer. 15.9. What is the difference between the Gross enrolment ratio (%) of Primary schools in 2003 and the Gross enrolment ratio (%) of Secondary schools in 2005?
Your answer should be compact. 4.74. What is the difference between the Gross enrolment ratio (%) in Primary schools in 2003 and the Gross enrolment ratio (%) in Tertiary schools in 2005?
Make the answer very short. 46.56. What is the difference between the Gross enrolment ratio (%) of Secondary schools in 2003 and the Gross enrolment ratio (%) of Tertiary schools in 2005?
Provide a short and direct response. 42.91. What is the difference between the Gross enrolment ratio (%) of Pre-primary schools in 2003 and the Gross enrolment ratio (%) of Primary schools in 2006?
Offer a terse response. -30.88. What is the difference between the Gross enrolment ratio (%) in Pre-primary schools in 2003 and the Gross enrolment ratio (%) in Secondary schools in 2006?
Make the answer very short. -25.83. What is the difference between the Gross enrolment ratio (%) in Pre-primary schools in 2003 and the Gross enrolment ratio (%) in Tertiary schools in 2006?
Offer a very short reply. 15.13. What is the difference between the Gross enrolment ratio (%) of Primary schools in 2003 and the Gross enrolment ratio (%) of Secondary schools in 2006?
Your response must be concise. 4.83. What is the difference between the Gross enrolment ratio (%) of Primary schools in 2003 and the Gross enrolment ratio (%) of Tertiary schools in 2006?
Keep it short and to the point. 45.78. What is the difference between the Gross enrolment ratio (%) in Secondary schools in 2003 and the Gross enrolment ratio (%) in Tertiary schools in 2006?
Offer a terse response. 42.14. What is the difference between the Gross enrolment ratio (%) in Pre-primary schools in 2003 and the Gross enrolment ratio (%) in Primary schools in 2007?
Provide a short and direct response. -31.54. What is the difference between the Gross enrolment ratio (%) in Pre-primary schools in 2003 and the Gross enrolment ratio (%) in Secondary schools in 2007?
Your answer should be compact. -25.89. What is the difference between the Gross enrolment ratio (%) in Pre-primary schools in 2003 and the Gross enrolment ratio (%) in Tertiary schools in 2007?
Your response must be concise. 14.38. What is the difference between the Gross enrolment ratio (%) of Primary schools in 2003 and the Gross enrolment ratio (%) of Secondary schools in 2007?
Give a very brief answer. 4.76. What is the difference between the Gross enrolment ratio (%) of Primary schools in 2003 and the Gross enrolment ratio (%) of Tertiary schools in 2007?
Make the answer very short. 45.04. What is the difference between the Gross enrolment ratio (%) in Secondary schools in 2003 and the Gross enrolment ratio (%) in Tertiary schools in 2007?
Keep it short and to the point. 41.4. What is the difference between the Gross enrolment ratio (%) in Pre-primary schools in 2004 and the Gross enrolment ratio (%) in Primary schools in 2005?
Offer a very short reply. -30.04. What is the difference between the Gross enrolment ratio (%) of Pre-primary schools in 2004 and the Gross enrolment ratio (%) of Secondary schools in 2005?
Give a very brief answer. -24.95. What is the difference between the Gross enrolment ratio (%) of Pre-primary schools in 2004 and the Gross enrolment ratio (%) of Tertiary schools in 2005?
Give a very brief answer. 16.86. What is the difference between the Gross enrolment ratio (%) of Primary schools in 2004 and the Gross enrolment ratio (%) of Secondary schools in 2005?
Make the answer very short. 4.78. What is the difference between the Gross enrolment ratio (%) of Primary schools in 2004 and the Gross enrolment ratio (%) of Tertiary schools in 2005?
Give a very brief answer. 46.6. What is the difference between the Gross enrolment ratio (%) in Secondary schools in 2004 and the Gross enrolment ratio (%) in Tertiary schools in 2005?
Give a very brief answer. 41.57. What is the difference between the Gross enrolment ratio (%) of Pre-primary schools in 2004 and the Gross enrolment ratio (%) of Primary schools in 2006?
Make the answer very short. -29.92. What is the difference between the Gross enrolment ratio (%) in Pre-primary schools in 2004 and the Gross enrolment ratio (%) in Secondary schools in 2006?
Offer a very short reply. -24.87. What is the difference between the Gross enrolment ratio (%) of Pre-primary schools in 2004 and the Gross enrolment ratio (%) of Tertiary schools in 2006?
Your answer should be compact. 16.09. What is the difference between the Gross enrolment ratio (%) in Primary schools in 2004 and the Gross enrolment ratio (%) in Secondary schools in 2006?
Your answer should be compact. 4.87. What is the difference between the Gross enrolment ratio (%) of Primary schools in 2004 and the Gross enrolment ratio (%) of Tertiary schools in 2006?
Offer a very short reply. 45.82. What is the difference between the Gross enrolment ratio (%) of Secondary schools in 2004 and the Gross enrolment ratio (%) of Tertiary schools in 2006?
Provide a short and direct response. 40.8. What is the difference between the Gross enrolment ratio (%) of Pre-primary schools in 2004 and the Gross enrolment ratio (%) of Primary schools in 2007?
Keep it short and to the point. -30.57. What is the difference between the Gross enrolment ratio (%) in Pre-primary schools in 2004 and the Gross enrolment ratio (%) in Secondary schools in 2007?
Provide a short and direct response. -24.93. What is the difference between the Gross enrolment ratio (%) of Pre-primary schools in 2004 and the Gross enrolment ratio (%) of Tertiary schools in 2007?
Provide a succinct answer. 15.35. What is the difference between the Gross enrolment ratio (%) in Primary schools in 2004 and the Gross enrolment ratio (%) in Secondary schools in 2007?
Your answer should be compact. 4.8. What is the difference between the Gross enrolment ratio (%) of Primary schools in 2004 and the Gross enrolment ratio (%) of Tertiary schools in 2007?
Your response must be concise. 45.08. What is the difference between the Gross enrolment ratio (%) in Secondary schools in 2004 and the Gross enrolment ratio (%) in Tertiary schools in 2007?
Give a very brief answer. 40.05. What is the difference between the Gross enrolment ratio (%) of Pre-primary schools in 2005 and the Gross enrolment ratio (%) of Primary schools in 2006?
Your answer should be compact. -27.58. What is the difference between the Gross enrolment ratio (%) in Pre-primary schools in 2005 and the Gross enrolment ratio (%) in Secondary schools in 2006?
Give a very brief answer. -22.53. What is the difference between the Gross enrolment ratio (%) of Pre-primary schools in 2005 and the Gross enrolment ratio (%) of Tertiary schools in 2006?
Ensure brevity in your answer.  18.42. What is the difference between the Gross enrolment ratio (%) of Primary schools in 2005 and the Gross enrolment ratio (%) of Secondary schools in 2006?
Offer a terse response. 5.17. What is the difference between the Gross enrolment ratio (%) in Primary schools in 2005 and the Gross enrolment ratio (%) in Tertiary schools in 2006?
Offer a very short reply. 46.13. What is the difference between the Gross enrolment ratio (%) of Secondary schools in 2005 and the Gross enrolment ratio (%) of Tertiary schools in 2006?
Offer a very short reply. 41.04. What is the difference between the Gross enrolment ratio (%) of Pre-primary schools in 2005 and the Gross enrolment ratio (%) of Primary schools in 2007?
Your answer should be very brief. -28.24. What is the difference between the Gross enrolment ratio (%) in Pre-primary schools in 2005 and the Gross enrolment ratio (%) in Secondary schools in 2007?
Offer a terse response. -22.6. What is the difference between the Gross enrolment ratio (%) of Pre-primary schools in 2005 and the Gross enrolment ratio (%) of Tertiary schools in 2007?
Give a very brief answer. 17.68. What is the difference between the Gross enrolment ratio (%) of Primary schools in 2005 and the Gross enrolment ratio (%) of Secondary schools in 2007?
Provide a succinct answer. 5.11. What is the difference between the Gross enrolment ratio (%) of Primary schools in 2005 and the Gross enrolment ratio (%) of Tertiary schools in 2007?
Your answer should be very brief. 45.38. What is the difference between the Gross enrolment ratio (%) in Secondary schools in 2005 and the Gross enrolment ratio (%) in Tertiary schools in 2007?
Make the answer very short. 40.3. What is the difference between the Gross enrolment ratio (%) in Pre-primary schools in 2006 and the Gross enrolment ratio (%) in Primary schools in 2007?
Keep it short and to the point. -27.09. What is the difference between the Gross enrolment ratio (%) in Pre-primary schools in 2006 and the Gross enrolment ratio (%) in Secondary schools in 2007?
Your response must be concise. -21.45. What is the difference between the Gross enrolment ratio (%) in Pre-primary schools in 2006 and the Gross enrolment ratio (%) in Tertiary schools in 2007?
Provide a short and direct response. 18.83. What is the difference between the Gross enrolment ratio (%) of Primary schools in 2006 and the Gross enrolment ratio (%) of Secondary schools in 2007?
Give a very brief answer. 4.98. What is the difference between the Gross enrolment ratio (%) in Primary schools in 2006 and the Gross enrolment ratio (%) in Tertiary schools in 2007?
Offer a very short reply. 45.26. What is the difference between the Gross enrolment ratio (%) in Secondary schools in 2006 and the Gross enrolment ratio (%) in Tertiary schools in 2007?
Your answer should be compact. 40.21. What is the average Gross enrolment ratio (%) of Pre-primary schools per year?
Give a very brief answer. 72.77. What is the average Gross enrolment ratio (%) of Primary schools per year?
Provide a succinct answer. 102.71. What is the average Gross enrolment ratio (%) of Secondary schools per year?
Make the answer very short. 97.02. What is the average Gross enrolment ratio (%) in Tertiary schools per year?
Your answer should be compact. 53.53. In the year 2000, what is the difference between the Gross enrolment ratio (%) of Pre-primary schools and Gross enrolment ratio (%) of Primary schools?
Give a very brief answer. -35.03. In the year 2000, what is the difference between the Gross enrolment ratio (%) in Pre-primary schools and Gross enrolment ratio (%) in Secondary schools?
Ensure brevity in your answer.  -26.02. In the year 2000, what is the difference between the Gross enrolment ratio (%) in Pre-primary schools and Gross enrolment ratio (%) in Tertiary schools?
Provide a short and direct response. 20.3. In the year 2000, what is the difference between the Gross enrolment ratio (%) of Primary schools and Gross enrolment ratio (%) of Secondary schools?
Provide a short and direct response. 9.01. In the year 2000, what is the difference between the Gross enrolment ratio (%) of Primary schools and Gross enrolment ratio (%) of Tertiary schools?
Offer a terse response. 55.33. In the year 2000, what is the difference between the Gross enrolment ratio (%) of Secondary schools and Gross enrolment ratio (%) of Tertiary schools?
Your answer should be compact. 46.32. In the year 2001, what is the difference between the Gross enrolment ratio (%) in Pre-primary schools and Gross enrolment ratio (%) in Primary schools?
Provide a short and direct response. -33. In the year 2001, what is the difference between the Gross enrolment ratio (%) in Pre-primary schools and Gross enrolment ratio (%) in Secondary schools?
Provide a short and direct response. -25.84. In the year 2001, what is the difference between the Gross enrolment ratio (%) in Pre-primary schools and Gross enrolment ratio (%) in Tertiary schools?
Your answer should be compact. 20.81. In the year 2001, what is the difference between the Gross enrolment ratio (%) in Primary schools and Gross enrolment ratio (%) in Secondary schools?
Your response must be concise. 7.16. In the year 2001, what is the difference between the Gross enrolment ratio (%) of Primary schools and Gross enrolment ratio (%) of Tertiary schools?
Your response must be concise. 53.81. In the year 2001, what is the difference between the Gross enrolment ratio (%) in Secondary schools and Gross enrolment ratio (%) in Tertiary schools?
Your answer should be very brief. 46.65. In the year 2002, what is the difference between the Gross enrolment ratio (%) in Pre-primary schools and Gross enrolment ratio (%) in Primary schools?
Provide a succinct answer. -31.29. In the year 2002, what is the difference between the Gross enrolment ratio (%) in Pre-primary schools and Gross enrolment ratio (%) in Secondary schools?
Keep it short and to the point. -26.36. In the year 2002, what is the difference between the Gross enrolment ratio (%) of Pre-primary schools and Gross enrolment ratio (%) of Tertiary schools?
Your answer should be very brief. 18.52. In the year 2002, what is the difference between the Gross enrolment ratio (%) of Primary schools and Gross enrolment ratio (%) of Secondary schools?
Ensure brevity in your answer.  4.93. In the year 2002, what is the difference between the Gross enrolment ratio (%) of Primary schools and Gross enrolment ratio (%) of Tertiary schools?
Your answer should be compact. 49.81. In the year 2002, what is the difference between the Gross enrolment ratio (%) in Secondary schools and Gross enrolment ratio (%) in Tertiary schools?
Your answer should be very brief. 44.88. In the year 2003, what is the difference between the Gross enrolment ratio (%) in Pre-primary schools and Gross enrolment ratio (%) in Primary schools?
Provide a succinct answer. -30.66. In the year 2003, what is the difference between the Gross enrolment ratio (%) in Pre-primary schools and Gross enrolment ratio (%) in Secondary schools?
Give a very brief answer. -27.01. In the year 2003, what is the difference between the Gross enrolment ratio (%) in Pre-primary schools and Gross enrolment ratio (%) in Tertiary schools?
Offer a terse response. 17.49. In the year 2003, what is the difference between the Gross enrolment ratio (%) of Primary schools and Gross enrolment ratio (%) of Secondary schools?
Ensure brevity in your answer.  3.64. In the year 2003, what is the difference between the Gross enrolment ratio (%) of Primary schools and Gross enrolment ratio (%) of Tertiary schools?
Make the answer very short. 48.14. In the year 2003, what is the difference between the Gross enrolment ratio (%) in Secondary schools and Gross enrolment ratio (%) in Tertiary schools?
Make the answer very short. 44.5. In the year 2004, what is the difference between the Gross enrolment ratio (%) of Pre-primary schools and Gross enrolment ratio (%) of Primary schools?
Provide a succinct answer. -29.73. In the year 2004, what is the difference between the Gross enrolment ratio (%) in Pre-primary schools and Gross enrolment ratio (%) in Secondary schools?
Provide a short and direct response. -24.71. In the year 2004, what is the difference between the Gross enrolment ratio (%) of Pre-primary schools and Gross enrolment ratio (%) of Tertiary schools?
Your answer should be very brief. 17.8. In the year 2004, what is the difference between the Gross enrolment ratio (%) of Primary schools and Gross enrolment ratio (%) of Secondary schools?
Keep it short and to the point. 5.03. In the year 2004, what is the difference between the Gross enrolment ratio (%) of Primary schools and Gross enrolment ratio (%) of Tertiary schools?
Your response must be concise. 47.54. In the year 2004, what is the difference between the Gross enrolment ratio (%) of Secondary schools and Gross enrolment ratio (%) of Tertiary schools?
Make the answer very short. 42.51. In the year 2005, what is the difference between the Gross enrolment ratio (%) of Pre-primary schools and Gross enrolment ratio (%) of Primary schools?
Give a very brief answer. -27.7. In the year 2005, what is the difference between the Gross enrolment ratio (%) in Pre-primary schools and Gross enrolment ratio (%) in Secondary schools?
Give a very brief answer. -22.62. In the year 2005, what is the difference between the Gross enrolment ratio (%) of Pre-primary schools and Gross enrolment ratio (%) of Tertiary schools?
Make the answer very short. 19.2. In the year 2005, what is the difference between the Gross enrolment ratio (%) of Primary schools and Gross enrolment ratio (%) of Secondary schools?
Ensure brevity in your answer.  5.09. In the year 2005, what is the difference between the Gross enrolment ratio (%) in Primary schools and Gross enrolment ratio (%) in Tertiary schools?
Ensure brevity in your answer.  46.9. In the year 2005, what is the difference between the Gross enrolment ratio (%) in Secondary schools and Gross enrolment ratio (%) in Tertiary schools?
Make the answer very short. 41.82. In the year 2006, what is the difference between the Gross enrolment ratio (%) in Pre-primary schools and Gross enrolment ratio (%) in Primary schools?
Give a very brief answer. -26.43. In the year 2006, what is the difference between the Gross enrolment ratio (%) in Pre-primary schools and Gross enrolment ratio (%) in Secondary schools?
Offer a terse response. -21.39. In the year 2006, what is the difference between the Gross enrolment ratio (%) in Pre-primary schools and Gross enrolment ratio (%) in Tertiary schools?
Offer a terse response. 19.57. In the year 2006, what is the difference between the Gross enrolment ratio (%) in Primary schools and Gross enrolment ratio (%) in Secondary schools?
Offer a very short reply. 5.05. In the year 2006, what is the difference between the Gross enrolment ratio (%) of Primary schools and Gross enrolment ratio (%) of Tertiary schools?
Provide a short and direct response. 46. In the year 2006, what is the difference between the Gross enrolment ratio (%) of Secondary schools and Gross enrolment ratio (%) of Tertiary schools?
Make the answer very short. 40.96. In the year 2007, what is the difference between the Gross enrolment ratio (%) in Pre-primary schools and Gross enrolment ratio (%) in Primary schools?
Provide a short and direct response. -25.71. In the year 2007, what is the difference between the Gross enrolment ratio (%) in Pre-primary schools and Gross enrolment ratio (%) in Secondary schools?
Keep it short and to the point. -20.07. In the year 2007, what is the difference between the Gross enrolment ratio (%) of Pre-primary schools and Gross enrolment ratio (%) of Tertiary schools?
Provide a short and direct response. 20.21. In the year 2007, what is the difference between the Gross enrolment ratio (%) of Primary schools and Gross enrolment ratio (%) of Secondary schools?
Give a very brief answer. 5.64. In the year 2007, what is the difference between the Gross enrolment ratio (%) of Primary schools and Gross enrolment ratio (%) of Tertiary schools?
Ensure brevity in your answer.  45.92. In the year 2007, what is the difference between the Gross enrolment ratio (%) in Secondary schools and Gross enrolment ratio (%) in Tertiary schools?
Keep it short and to the point. 40.28. What is the ratio of the Gross enrolment ratio (%) of Pre-primary schools in 2000 to that in 2001?
Make the answer very short. 0.98. What is the ratio of the Gross enrolment ratio (%) of Primary schools in 2000 to that in 2001?
Your answer should be compact. 1. What is the ratio of the Gross enrolment ratio (%) of Secondary schools in 2000 to that in 2001?
Your answer should be compact. 0.98. What is the ratio of the Gross enrolment ratio (%) in Tertiary schools in 2000 to that in 2001?
Your response must be concise. 0.98. What is the ratio of the Gross enrolment ratio (%) of Pre-primary schools in 2000 to that in 2002?
Your response must be concise. 0.97. What is the ratio of the Gross enrolment ratio (%) in Primary schools in 2000 to that in 2002?
Make the answer very short. 1.01. What is the ratio of the Gross enrolment ratio (%) of Secondary schools in 2000 to that in 2002?
Ensure brevity in your answer.  0.97. What is the ratio of the Gross enrolment ratio (%) in Tertiary schools in 2000 to that in 2002?
Give a very brief answer. 0.92. What is the ratio of the Gross enrolment ratio (%) of Pre-primary schools in 2000 to that in 2003?
Ensure brevity in your answer.  0.96. What is the ratio of the Gross enrolment ratio (%) of Primary schools in 2000 to that in 2003?
Ensure brevity in your answer.  1.02. What is the ratio of the Gross enrolment ratio (%) of Secondary schools in 2000 to that in 2003?
Make the answer very short. 0.96. What is the ratio of the Gross enrolment ratio (%) in Tertiary schools in 2000 to that in 2003?
Provide a short and direct response. 0.9. What is the ratio of the Gross enrolment ratio (%) in Pre-primary schools in 2000 to that in 2004?
Offer a terse response. 0.95. What is the ratio of the Gross enrolment ratio (%) in Primary schools in 2000 to that in 2004?
Your answer should be very brief. 1.02. What is the ratio of the Gross enrolment ratio (%) of Secondary schools in 2000 to that in 2004?
Your answer should be very brief. 0.98. What is the ratio of the Gross enrolment ratio (%) in Tertiary schools in 2000 to that in 2004?
Offer a terse response. 0.89. What is the ratio of the Gross enrolment ratio (%) of Pre-primary schools in 2000 to that in 2005?
Give a very brief answer. 0.92. What is the ratio of the Gross enrolment ratio (%) of Primary schools in 2000 to that in 2005?
Give a very brief answer. 1.01. What is the ratio of the Gross enrolment ratio (%) of Secondary schools in 2000 to that in 2005?
Offer a very short reply. 0.97. What is the ratio of the Gross enrolment ratio (%) of Tertiary schools in 2000 to that in 2005?
Your answer should be very brief. 0.87. What is the ratio of the Gross enrolment ratio (%) in Pre-primary schools in 2000 to that in 2006?
Give a very brief answer. 0.91. What is the ratio of the Gross enrolment ratio (%) of Primary schools in 2000 to that in 2006?
Your answer should be compact. 1.01. What is the ratio of the Gross enrolment ratio (%) in Secondary schools in 2000 to that in 2006?
Offer a very short reply. 0.97. What is the ratio of the Gross enrolment ratio (%) of Tertiary schools in 2000 to that in 2006?
Your answer should be compact. 0.86. What is the ratio of the Gross enrolment ratio (%) of Pre-primary schools in 2000 to that in 2007?
Keep it short and to the point. 0.89. What is the ratio of the Gross enrolment ratio (%) in Primary schools in 2000 to that in 2007?
Your answer should be very brief. 1.01. What is the ratio of the Gross enrolment ratio (%) in Secondary schools in 2000 to that in 2007?
Your response must be concise. 0.97. What is the ratio of the Gross enrolment ratio (%) of Tertiary schools in 2000 to that in 2007?
Provide a short and direct response. 0.85. What is the ratio of the Gross enrolment ratio (%) in Pre-primary schools in 2001 to that in 2002?
Give a very brief answer. 0.99. What is the ratio of the Gross enrolment ratio (%) of Primary schools in 2001 to that in 2002?
Provide a short and direct response. 1.01. What is the ratio of the Gross enrolment ratio (%) in Secondary schools in 2001 to that in 2002?
Give a very brief answer. 0.99. What is the ratio of the Gross enrolment ratio (%) of Tertiary schools in 2001 to that in 2002?
Offer a very short reply. 0.94. What is the ratio of the Gross enrolment ratio (%) in Pre-primary schools in 2001 to that in 2003?
Ensure brevity in your answer.  0.99. What is the ratio of the Gross enrolment ratio (%) in Primary schools in 2001 to that in 2003?
Ensure brevity in your answer.  1.01. What is the ratio of the Gross enrolment ratio (%) in Secondary schools in 2001 to that in 2003?
Your response must be concise. 0.98. What is the ratio of the Gross enrolment ratio (%) in Tertiary schools in 2001 to that in 2003?
Your response must be concise. 0.92. What is the ratio of the Gross enrolment ratio (%) of Pre-primary schools in 2001 to that in 2004?
Provide a short and direct response. 0.97. What is the ratio of the Gross enrolment ratio (%) of Primary schools in 2001 to that in 2004?
Provide a succinct answer. 1.01. What is the ratio of the Gross enrolment ratio (%) in Secondary schools in 2001 to that in 2004?
Ensure brevity in your answer.  0.99. What is the ratio of the Gross enrolment ratio (%) in Tertiary schools in 2001 to that in 2004?
Offer a very short reply. 0.91. What is the ratio of the Gross enrolment ratio (%) of Pre-primary schools in 2001 to that in 2005?
Provide a succinct answer. 0.94. What is the ratio of the Gross enrolment ratio (%) of Secondary schools in 2001 to that in 2005?
Make the answer very short. 0.99. What is the ratio of the Gross enrolment ratio (%) in Tertiary schools in 2001 to that in 2005?
Your response must be concise. 0.89. What is the ratio of the Gross enrolment ratio (%) of Pre-primary schools in 2001 to that in 2006?
Provide a short and direct response. 0.93. What is the ratio of the Gross enrolment ratio (%) of Primary schools in 2001 to that in 2006?
Make the answer very short. 1.01. What is the ratio of the Gross enrolment ratio (%) of Secondary schools in 2001 to that in 2006?
Keep it short and to the point. 0.99. What is the ratio of the Gross enrolment ratio (%) in Tertiary schools in 2001 to that in 2006?
Give a very brief answer. 0.88. What is the ratio of the Gross enrolment ratio (%) in Pre-primary schools in 2001 to that in 2007?
Your response must be concise. 0.91. What is the ratio of the Gross enrolment ratio (%) of Tertiary schools in 2001 to that in 2007?
Offer a very short reply. 0.87. What is the ratio of the Gross enrolment ratio (%) of Primary schools in 2002 to that in 2003?
Your answer should be very brief. 1. What is the ratio of the Gross enrolment ratio (%) in Secondary schools in 2002 to that in 2003?
Your response must be concise. 0.99. What is the ratio of the Gross enrolment ratio (%) of Tertiary schools in 2002 to that in 2003?
Give a very brief answer. 0.98. What is the ratio of the Gross enrolment ratio (%) in Pre-primary schools in 2002 to that in 2004?
Keep it short and to the point. 0.98. What is the ratio of the Gross enrolment ratio (%) of Primary schools in 2002 to that in 2004?
Provide a succinct answer. 1. What is the ratio of the Gross enrolment ratio (%) of Secondary schools in 2002 to that in 2004?
Your response must be concise. 1. What is the ratio of the Gross enrolment ratio (%) of Tertiary schools in 2002 to that in 2004?
Give a very brief answer. 0.96. What is the ratio of the Gross enrolment ratio (%) in Primary schools in 2002 to that in 2005?
Your answer should be very brief. 1. What is the ratio of the Gross enrolment ratio (%) of Tertiary schools in 2002 to that in 2005?
Your answer should be very brief. 0.95. What is the ratio of the Gross enrolment ratio (%) of Pre-primary schools in 2002 to that in 2006?
Keep it short and to the point. 0.94. What is the ratio of the Gross enrolment ratio (%) in Primary schools in 2002 to that in 2006?
Ensure brevity in your answer.  1. What is the ratio of the Gross enrolment ratio (%) of Tertiary schools in 2002 to that in 2006?
Give a very brief answer. 0.93. What is the ratio of the Gross enrolment ratio (%) of Pre-primary schools in 2002 to that in 2007?
Your answer should be compact. 0.92. What is the ratio of the Gross enrolment ratio (%) in Secondary schools in 2002 to that in 2007?
Provide a succinct answer. 1. What is the ratio of the Gross enrolment ratio (%) of Tertiary schools in 2002 to that in 2007?
Ensure brevity in your answer.  0.92. What is the ratio of the Gross enrolment ratio (%) of Pre-primary schools in 2003 to that in 2004?
Ensure brevity in your answer.  0.99. What is the ratio of the Gross enrolment ratio (%) in Primary schools in 2003 to that in 2004?
Your answer should be very brief. 1. What is the ratio of the Gross enrolment ratio (%) in Secondary schools in 2003 to that in 2004?
Provide a succinct answer. 1.01. What is the ratio of the Gross enrolment ratio (%) of Tertiary schools in 2003 to that in 2004?
Keep it short and to the point. 0.99. What is the ratio of the Gross enrolment ratio (%) of Pre-primary schools in 2003 to that in 2005?
Your answer should be very brief. 0.96. What is the ratio of the Gross enrolment ratio (%) of Secondary schools in 2003 to that in 2005?
Your response must be concise. 1.01. What is the ratio of the Gross enrolment ratio (%) in Tertiary schools in 2003 to that in 2005?
Your response must be concise. 0.97. What is the ratio of the Gross enrolment ratio (%) of Pre-primary schools in 2003 to that in 2006?
Your answer should be compact. 0.94. What is the ratio of the Gross enrolment ratio (%) of Primary schools in 2003 to that in 2006?
Your response must be concise. 1. What is the ratio of the Gross enrolment ratio (%) in Secondary schools in 2003 to that in 2006?
Your answer should be very brief. 1.01. What is the ratio of the Gross enrolment ratio (%) in Tertiary schools in 2003 to that in 2006?
Offer a very short reply. 0.96. What is the ratio of the Gross enrolment ratio (%) of Pre-primary schools in 2003 to that in 2007?
Provide a short and direct response. 0.92. What is the ratio of the Gross enrolment ratio (%) of Secondary schools in 2003 to that in 2007?
Provide a succinct answer. 1.01. What is the ratio of the Gross enrolment ratio (%) of Tertiary schools in 2003 to that in 2007?
Offer a very short reply. 0.95. What is the ratio of the Gross enrolment ratio (%) of Pre-primary schools in 2004 to that in 2005?
Make the answer very short. 0.97. What is the ratio of the Gross enrolment ratio (%) in Tertiary schools in 2004 to that in 2005?
Give a very brief answer. 0.98. What is the ratio of the Gross enrolment ratio (%) in Pre-primary schools in 2004 to that in 2006?
Offer a very short reply. 0.95. What is the ratio of the Gross enrolment ratio (%) in Tertiary schools in 2004 to that in 2006?
Keep it short and to the point. 0.97. What is the ratio of the Gross enrolment ratio (%) of Pre-primary schools in 2004 to that in 2007?
Your answer should be very brief. 0.94. What is the ratio of the Gross enrolment ratio (%) in Primary schools in 2004 to that in 2007?
Your response must be concise. 0.99. What is the ratio of the Gross enrolment ratio (%) in Secondary schools in 2004 to that in 2007?
Provide a short and direct response. 1. What is the ratio of the Gross enrolment ratio (%) in Tertiary schools in 2004 to that in 2007?
Make the answer very short. 0.96. What is the ratio of the Gross enrolment ratio (%) of Pre-primary schools in 2005 to that in 2006?
Make the answer very short. 0.98. What is the ratio of the Gross enrolment ratio (%) of Primary schools in 2005 to that in 2006?
Your answer should be very brief. 1. What is the ratio of the Gross enrolment ratio (%) of Tertiary schools in 2005 to that in 2006?
Your answer should be very brief. 0.99. What is the ratio of the Gross enrolment ratio (%) of Pre-primary schools in 2005 to that in 2007?
Provide a succinct answer. 0.97. What is the ratio of the Gross enrolment ratio (%) of Primary schools in 2005 to that in 2007?
Offer a terse response. 0.99. What is the ratio of the Gross enrolment ratio (%) of Tertiary schools in 2005 to that in 2007?
Keep it short and to the point. 0.97. What is the ratio of the Gross enrolment ratio (%) in Pre-primary schools in 2006 to that in 2007?
Provide a succinct answer. 0.98. What is the ratio of the Gross enrolment ratio (%) of Primary schools in 2006 to that in 2007?
Ensure brevity in your answer.  0.99. What is the difference between the highest and the second highest Gross enrolment ratio (%) in Pre-primary schools?
Ensure brevity in your answer.  1.38. What is the difference between the highest and the second highest Gross enrolment ratio (%) of Primary schools?
Give a very brief answer. 0.35. What is the difference between the highest and the second highest Gross enrolment ratio (%) in Secondary schools?
Provide a succinct answer. 0.94. What is the difference between the highest and the second highest Gross enrolment ratio (%) in Tertiary schools?
Keep it short and to the point. 0.74. What is the difference between the highest and the lowest Gross enrolment ratio (%) of Pre-primary schools?
Offer a very short reply. 8.47. What is the difference between the highest and the lowest Gross enrolment ratio (%) of Primary schools?
Your response must be concise. 1.73. What is the difference between the highest and the lowest Gross enrolment ratio (%) of Secondary schools?
Keep it short and to the point. 3.63. What is the difference between the highest and the lowest Gross enrolment ratio (%) of Tertiary schools?
Offer a terse response. 8.55. 